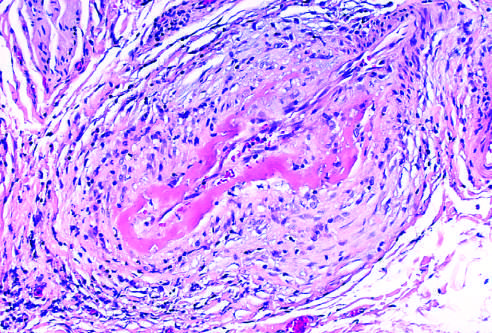s part of the vessel uninvolved?
Answer the question using a single word or phrase. Yes 